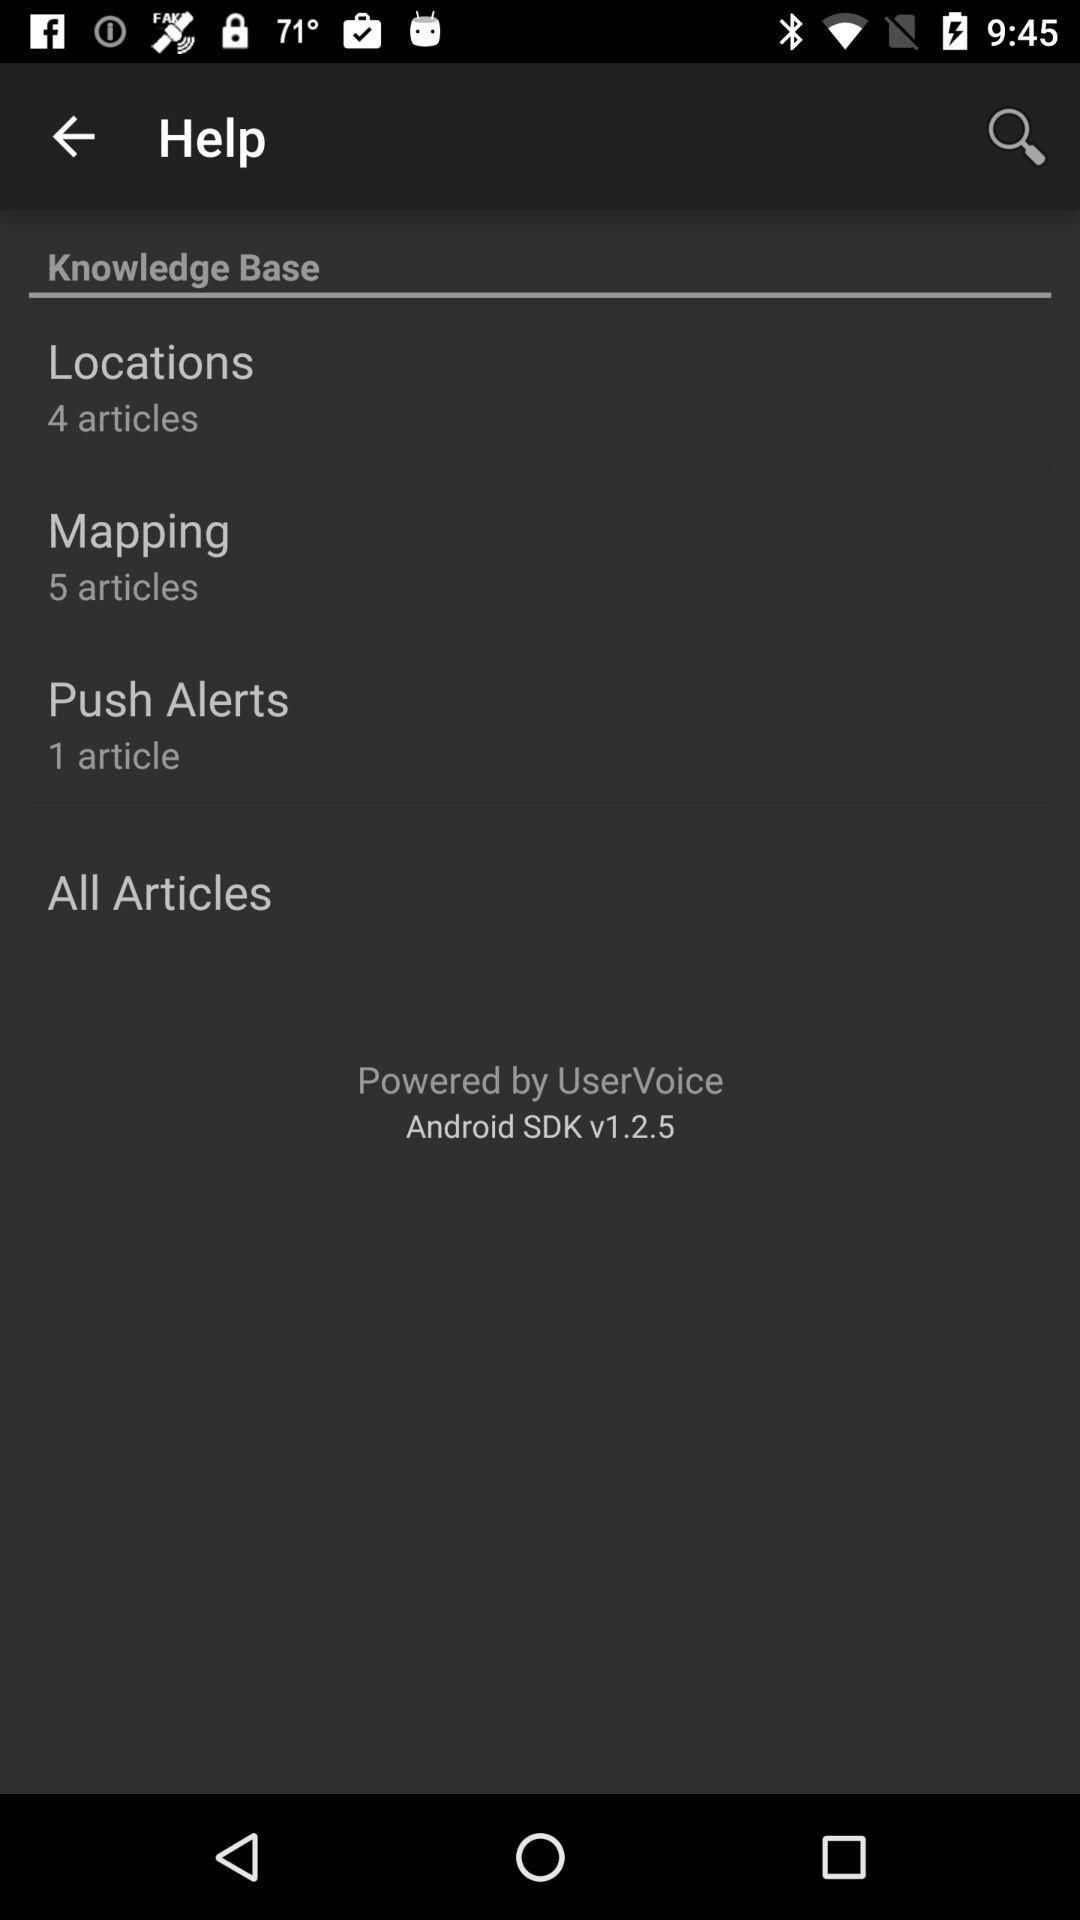By whom is it powered? It is powered by "UserVoice". 